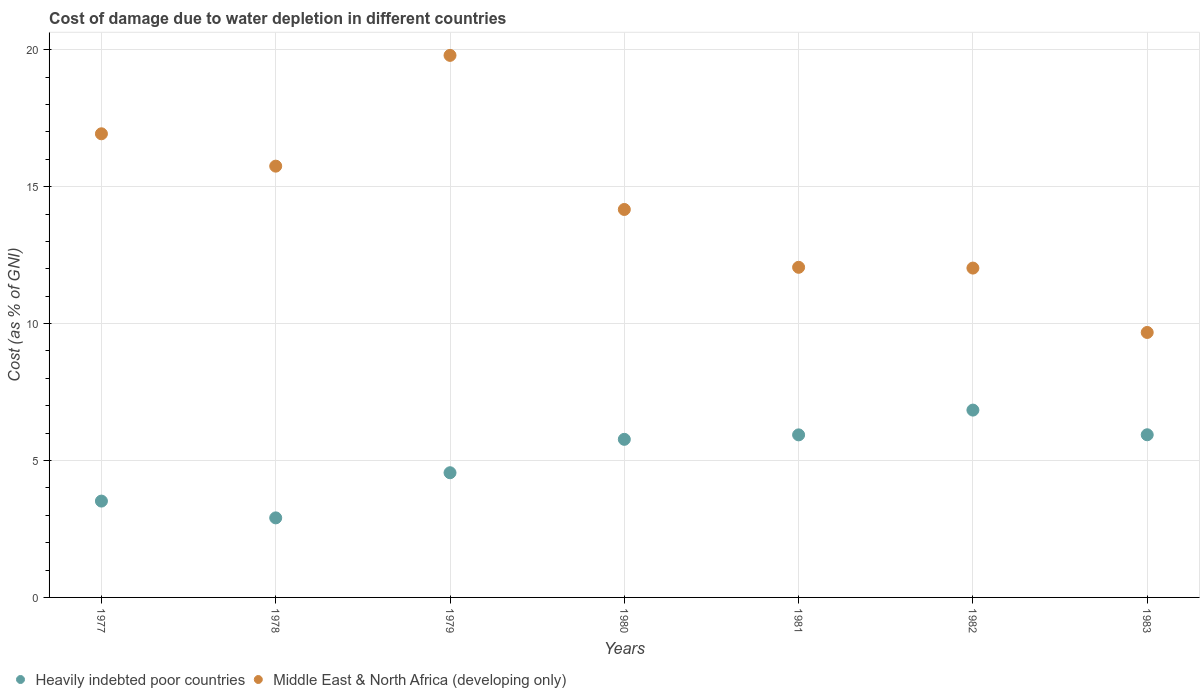How many different coloured dotlines are there?
Your answer should be very brief. 2. What is the cost of damage caused due to water depletion in Middle East & North Africa (developing only) in 1983?
Offer a very short reply. 9.68. Across all years, what is the maximum cost of damage caused due to water depletion in Heavily indebted poor countries?
Your answer should be very brief. 6.84. Across all years, what is the minimum cost of damage caused due to water depletion in Heavily indebted poor countries?
Provide a short and direct response. 2.9. In which year was the cost of damage caused due to water depletion in Heavily indebted poor countries maximum?
Provide a short and direct response. 1982. In which year was the cost of damage caused due to water depletion in Middle East & North Africa (developing only) minimum?
Provide a short and direct response. 1983. What is the total cost of damage caused due to water depletion in Middle East & North Africa (developing only) in the graph?
Provide a short and direct response. 100.4. What is the difference between the cost of damage caused due to water depletion in Middle East & North Africa (developing only) in 1979 and that in 1983?
Your response must be concise. 10.12. What is the difference between the cost of damage caused due to water depletion in Middle East & North Africa (developing only) in 1981 and the cost of damage caused due to water depletion in Heavily indebted poor countries in 1980?
Provide a short and direct response. 6.28. What is the average cost of damage caused due to water depletion in Heavily indebted poor countries per year?
Your answer should be very brief. 5.07. In the year 1981, what is the difference between the cost of damage caused due to water depletion in Middle East & North Africa (developing only) and cost of damage caused due to water depletion in Heavily indebted poor countries?
Make the answer very short. 6.12. In how many years, is the cost of damage caused due to water depletion in Heavily indebted poor countries greater than 3 %?
Offer a very short reply. 6. What is the ratio of the cost of damage caused due to water depletion in Heavily indebted poor countries in 1979 to that in 1980?
Ensure brevity in your answer.  0.79. Is the cost of damage caused due to water depletion in Heavily indebted poor countries in 1978 less than that in 1981?
Provide a succinct answer. Yes. Is the difference between the cost of damage caused due to water depletion in Middle East & North Africa (developing only) in 1979 and 1981 greater than the difference between the cost of damage caused due to water depletion in Heavily indebted poor countries in 1979 and 1981?
Give a very brief answer. Yes. What is the difference between the highest and the second highest cost of damage caused due to water depletion in Middle East & North Africa (developing only)?
Make the answer very short. 2.86. What is the difference between the highest and the lowest cost of damage caused due to water depletion in Heavily indebted poor countries?
Provide a short and direct response. 3.94. Is the sum of the cost of damage caused due to water depletion in Heavily indebted poor countries in 1981 and 1982 greater than the maximum cost of damage caused due to water depletion in Middle East & North Africa (developing only) across all years?
Offer a very short reply. No. Is the cost of damage caused due to water depletion in Heavily indebted poor countries strictly greater than the cost of damage caused due to water depletion in Middle East & North Africa (developing only) over the years?
Make the answer very short. No. Does the graph contain any zero values?
Ensure brevity in your answer.  No. How many legend labels are there?
Provide a short and direct response. 2. How are the legend labels stacked?
Provide a short and direct response. Horizontal. What is the title of the graph?
Make the answer very short. Cost of damage due to water depletion in different countries. What is the label or title of the X-axis?
Offer a terse response. Years. What is the label or title of the Y-axis?
Make the answer very short. Cost (as % of GNI). What is the Cost (as % of GNI) of Heavily indebted poor countries in 1977?
Your answer should be very brief. 3.52. What is the Cost (as % of GNI) in Middle East & North Africa (developing only) in 1977?
Ensure brevity in your answer.  16.93. What is the Cost (as % of GNI) in Heavily indebted poor countries in 1978?
Give a very brief answer. 2.9. What is the Cost (as % of GNI) of Middle East & North Africa (developing only) in 1978?
Your response must be concise. 15.75. What is the Cost (as % of GNI) of Heavily indebted poor countries in 1979?
Provide a short and direct response. 4.55. What is the Cost (as % of GNI) in Middle East & North Africa (developing only) in 1979?
Your answer should be compact. 19.79. What is the Cost (as % of GNI) in Heavily indebted poor countries in 1980?
Provide a succinct answer. 5.77. What is the Cost (as % of GNI) in Middle East & North Africa (developing only) in 1980?
Offer a very short reply. 14.17. What is the Cost (as % of GNI) of Heavily indebted poor countries in 1981?
Provide a succinct answer. 5.94. What is the Cost (as % of GNI) in Middle East & North Africa (developing only) in 1981?
Your response must be concise. 12.05. What is the Cost (as % of GNI) of Heavily indebted poor countries in 1982?
Ensure brevity in your answer.  6.84. What is the Cost (as % of GNI) of Middle East & North Africa (developing only) in 1982?
Offer a terse response. 12.03. What is the Cost (as % of GNI) of Heavily indebted poor countries in 1983?
Make the answer very short. 5.94. What is the Cost (as % of GNI) in Middle East & North Africa (developing only) in 1983?
Provide a succinct answer. 9.68. Across all years, what is the maximum Cost (as % of GNI) of Heavily indebted poor countries?
Provide a succinct answer. 6.84. Across all years, what is the maximum Cost (as % of GNI) in Middle East & North Africa (developing only)?
Your response must be concise. 19.79. Across all years, what is the minimum Cost (as % of GNI) of Heavily indebted poor countries?
Your response must be concise. 2.9. Across all years, what is the minimum Cost (as % of GNI) in Middle East & North Africa (developing only)?
Provide a short and direct response. 9.68. What is the total Cost (as % of GNI) of Heavily indebted poor countries in the graph?
Offer a terse response. 35.47. What is the total Cost (as % of GNI) in Middle East & North Africa (developing only) in the graph?
Your answer should be compact. 100.4. What is the difference between the Cost (as % of GNI) of Heavily indebted poor countries in 1977 and that in 1978?
Keep it short and to the point. 0.61. What is the difference between the Cost (as % of GNI) in Middle East & North Africa (developing only) in 1977 and that in 1978?
Provide a succinct answer. 1.18. What is the difference between the Cost (as % of GNI) in Heavily indebted poor countries in 1977 and that in 1979?
Provide a succinct answer. -1.04. What is the difference between the Cost (as % of GNI) of Middle East & North Africa (developing only) in 1977 and that in 1979?
Your response must be concise. -2.86. What is the difference between the Cost (as % of GNI) of Heavily indebted poor countries in 1977 and that in 1980?
Keep it short and to the point. -2.26. What is the difference between the Cost (as % of GNI) in Middle East & North Africa (developing only) in 1977 and that in 1980?
Your answer should be compact. 2.76. What is the difference between the Cost (as % of GNI) of Heavily indebted poor countries in 1977 and that in 1981?
Provide a short and direct response. -2.42. What is the difference between the Cost (as % of GNI) of Middle East & North Africa (developing only) in 1977 and that in 1981?
Provide a short and direct response. 4.88. What is the difference between the Cost (as % of GNI) in Heavily indebted poor countries in 1977 and that in 1982?
Your response must be concise. -3.32. What is the difference between the Cost (as % of GNI) of Middle East & North Africa (developing only) in 1977 and that in 1982?
Keep it short and to the point. 4.9. What is the difference between the Cost (as % of GNI) in Heavily indebted poor countries in 1977 and that in 1983?
Ensure brevity in your answer.  -2.42. What is the difference between the Cost (as % of GNI) of Middle East & North Africa (developing only) in 1977 and that in 1983?
Provide a succinct answer. 7.25. What is the difference between the Cost (as % of GNI) of Heavily indebted poor countries in 1978 and that in 1979?
Ensure brevity in your answer.  -1.65. What is the difference between the Cost (as % of GNI) in Middle East & North Africa (developing only) in 1978 and that in 1979?
Provide a succinct answer. -4.04. What is the difference between the Cost (as % of GNI) in Heavily indebted poor countries in 1978 and that in 1980?
Your response must be concise. -2.87. What is the difference between the Cost (as % of GNI) in Middle East & North Africa (developing only) in 1978 and that in 1980?
Your answer should be very brief. 1.58. What is the difference between the Cost (as % of GNI) of Heavily indebted poor countries in 1978 and that in 1981?
Your response must be concise. -3.03. What is the difference between the Cost (as % of GNI) of Middle East & North Africa (developing only) in 1978 and that in 1981?
Your response must be concise. 3.69. What is the difference between the Cost (as % of GNI) in Heavily indebted poor countries in 1978 and that in 1982?
Offer a terse response. -3.94. What is the difference between the Cost (as % of GNI) in Middle East & North Africa (developing only) in 1978 and that in 1982?
Your response must be concise. 3.72. What is the difference between the Cost (as % of GNI) of Heavily indebted poor countries in 1978 and that in 1983?
Provide a succinct answer. -3.03. What is the difference between the Cost (as % of GNI) of Middle East & North Africa (developing only) in 1978 and that in 1983?
Keep it short and to the point. 6.07. What is the difference between the Cost (as % of GNI) in Heavily indebted poor countries in 1979 and that in 1980?
Provide a succinct answer. -1.22. What is the difference between the Cost (as % of GNI) in Middle East & North Africa (developing only) in 1979 and that in 1980?
Keep it short and to the point. 5.63. What is the difference between the Cost (as % of GNI) of Heavily indebted poor countries in 1979 and that in 1981?
Provide a short and direct response. -1.38. What is the difference between the Cost (as % of GNI) of Middle East & North Africa (developing only) in 1979 and that in 1981?
Provide a short and direct response. 7.74. What is the difference between the Cost (as % of GNI) in Heavily indebted poor countries in 1979 and that in 1982?
Your response must be concise. -2.29. What is the difference between the Cost (as % of GNI) of Middle East & North Africa (developing only) in 1979 and that in 1982?
Keep it short and to the point. 7.77. What is the difference between the Cost (as % of GNI) of Heavily indebted poor countries in 1979 and that in 1983?
Provide a succinct answer. -1.39. What is the difference between the Cost (as % of GNI) in Middle East & North Africa (developing only) in 1979 and that in 1983?
Your answer should be very brief. 10.12. What is the difference between the Cost (as % of GNI) in Heavily indebted poor countries in 1980 and that in 1981?
Offer a very short reply. -0.16. What is the difference between the Cost (as % of GNI) of Middle East & North Africa (developing only) in 1980 and that in 1981?
Offer a very short reply. 2.11. What is the difference between the Cost (as % of GNI) in Heavily indebted poor countries in 1980 and that in 1982?
Provide a short and direct response. -1.07. What is the difference between the Cost (as % of GNI) of Middle East & North Africa (developing only) in 1980 and that in 1982?
Provide a succinct answer. 2.14. What is the difference between the Cost (as % of GNI) of Heavily indebted poor countries in 1980 and that in 1983?
Ensure brevity in your answer.  -0.17. What is the difference between the Cost (as % of GNI) of Middle East & North Africa (developing only) in 1980 and that in 1983?
Your answer should be very brief. 4.49. What is the difference between the Cost (as % of GNI) in Heavily indebted poor countries in 1981 and that in 1982?
Make the answer very short. -0.9. What is the difference between the Cost (as % of GNI) in Middle East & North Africa (developing only) in 1981 and that in 1982?
Ensure brevity in your answer.  0.03. What is the difference between the Cost (as % of GNI) in Heavily indebted poor countries in 1981 and that in 1983?
Make the answer very short. -0. What is the difference between the Cost (as % of GNI) of Middle East & North Africa (developing only) in 1981 and that in 1983?
Make the answer very short. 2.38. What is the difference between the Cost (as % of GNI) in Heavily indebted poor countries in 1982 and that in 1983?
Keep it short and to the point. 0.9. What is the difference between the Cost (as % of GNI) in Middle East & North Africa (developing only) in 1982 and that in 1983?
Offer a terse response. 2.35. What is the difference between the Cost (as % of GNI) in Heavily indebted poor countries in 1977 and the Cost (as % of GNI) in Middle East & North Africa (developing only) in 1978?
Your answer should be compact. -12.23. What is the difference between the Cost (as % of GNI) in Heavily indebted poor countries in 1977 and the Cost (as % of GNI) in Middle East & North Africa (developing only) in 1979?
Offer a terse response. -16.28. What is the difference between the Cost (as % of GNI) in Heavily indebted poor countries in 1977 and the Cost (as % of GNI) in Middle East & North Africa (developing only) in 1980?
Your answer should be compact. -10.65. What is the difference between the Cost (as % of GNI) in Heavily indebted poor countries in 1977 and the Cost (as % of GNI) in Middle East & North Africa (developing only) in 1981?
Make the answer very short. -8.54. What is the difference between the Cost (as % of GNI) of Heavily indebted poor countries in 1977 and the Cost (as % of GNI) of Middle East & North Africa (developing only) in 1982?
Offer a terse response. -8.51. What is the difference between the Cost (as % of GNI) in Heavily indebted poor countries in 1977 and the Cost (as % of GNI) in Middle East & North Africa (developing only) in 1983?
Give a very brief answer. -6.16. What is the difference between the Cost (as % of GNI) in Heavily indebted poor countries in 1978 and the Cost (as % of GNI) in Middle East & North Africa (developing only) in 1979?
Give a very brief answer. -16.89. What is the difference between the Cost (as % of GNI) in Heavily indebted poor countries in 1978 and the Cost (as % of GNI) in Middle East & North Africa (developing only) in 1980?
Ensure brevity in your answer.  -11.26. What is the difference between the Cost (as % of GNI) in Heavily indebted poor countries in 1978 and the Cost (as % of GNI) in Middle East & North Africa (developing only) in 1981?
Ensure brevity in your answer.  -9.15. What is the difference between the Cost (as % of GNI) of Heavily indebted poor countries in 1978 and the Cost (as % of GNI) of Middle East & North Africa (developing only) in 1982?
Your answer should be compact. -9.12. What is the difference between the Cost (as % of GNI) in Heavily indebted poor countries in 1978 and the Cost (as % of GNI) in Middle East & North Africa (developing only) in 1983?
Your response must be concise. -6.77. What is the difference between the Cost (as % of GNI) of Heavily indebted poor countries in 1979 and the Cost (as % of GNI) of Middle East & North Africa (developing only) in 1980?
Your answer should be compact. -9.61. What is the difference between the Cost (as % of GNI) of Heavily indebted poor countries in 1979 and the Cost (as % of GNI) of Middle East & North Africa (developing only) in 1981?
Your answer should be very brief. -7.5. What is the difference between the Cost (as % of GNI) of Heavily indebted poor countries in 1979 and the Cost (as % of GNI) of Middle East & North Africa (developing only) in 1982?
Make the answer very short. -7.47. What is the difference between the Cost (as % of GNI) in Heavily indebted poor countries in 1979 and the Cost (as % of GNI) in Middle East & North Africa (developing only) in 1983?
Provide a short and direct response. -5.12. What is the difference between the Cost (as % of GNI) in Heavily indebted poor countries in 1980 and the Cost (as % of GNI) in Middle East & North Africa (developing only) in 1981?
Provide a succinct answer. -6.28. What is the difference between the Cost (as % of GNI) of Heavily indebted poor countries in 1980 and the Cost (as % of GNI) of Middle East & North Africa (developing only) in 1982?
Your response must be concise. -6.25. What is the difference between the Cost (as % of GNI) of Heavily indebted poor countries in 1980 and the Cost (as % of GNI) of Middle East & North Africa (developing only) in 1983?
Your answer should be very brief. -3.9. What is the difference between the Cost (as % of GNI) in Heavily indebted poor countries in 1981 and the Cost (as % of GNI) in Middle East & North Africa (developing only) in 1982?
Your answer should be very brief. -6.09. What is the difference between the Cost (as % of GNI) of Heavily indebted poor countries in 1981 and the Cost (as % of GNI) of Middle East & North Africa (developing only) in 1983?
Keep it short and to the point. -3.74. What is the difference between the Cost (as % of GNI) in Heavily indebted poor countries in 1982 and the Cost (as % of GNI) in Middle East & North Africa (developing only) in 1983?
Provide a short and direct response. -2.83. What is the average Cost (as % of GNI) in Heavily indebted poor countries per year?
Provide a short and direct response. 5.07. What is the average Cost (as % of GNI) in Middle East & North Africa (developing only) per year?
Your answer should be compact. 14.34. In the year 1977, what is the difference between the Cost (as % of GNI) of Heavily indebted poor countries and Cost (as % of GNI) of Middle East & North Africa (developing only)?
Ensure brevity in your answer.  -13.41. In the year 1978, what is the difference between the Cost (as % of GNI) in Heavily indebted poor countries and Cost (as % of GNI) in Middle East & North Africa (developing only)?
Your response must be concise. -12.84. In the year 1979, what is the difference between the Cost (as % of GNI) in Heavily indebted poor countries and Cost (as % of GNI) in Middle East & North Africa (developing only)?
Provide a succinct answer. -15.24. In the year 1980, what is the difference between the Cost (as % of GNI) of Heavily indebted poor countries and Cost (as % of GNI) of Middle East & North Africa (developing only)?
Your answer should be very brief. -8.39. In the year 1981, what is the difference between the Cost (as % of GNI) of Heavily indebted poor countries and Cost (as % of GNI) of Middle East & North Africa (developing only)?
Provide a succinct answer. -6.12. In the year 1982, what is the difference between the Cost (as % of GNI) in Heavily indebted poor countries and Cost (as % of GNI) in Middle East & North Africa (developing only)?
Your answer should be compact. -5.19. In the year 1983, what is the difference between the Cost (as % of GNI) in Heavily indebted poor countries and Cost (as % of GNI) in Middle East & North Africa (developing only)?
Provide a succinct answer. -3.74. What is the ratio of the Cost (as % of GNI) in Heavily indebted poor countries in 1977 to that in 1978?
Provide a short and direct response. 1.21. What is the ratio of the Cost (as % of GNI) in Middle East & North Africa (developing only) in 1977 to that in 1978?
Your answer should be very brief. 1.07. What is the ratio of the Cost (as % of GNI) in Heavily indebted poor countries in 1977 to that in 1979?
Ensure brevity in your answer.  0.77. What is the ratio of the Cost (as % of GNI) of Middle East & North Africa (developing only) in 1977 to that in 1979?
Provide a succinct answer. 0.86. What is the ratio of the Cost (as % of GNI) in Heavily indebted poor countries in 1977 to that in 1980?
Provide a succinct answer. 0.61. What is the ratio of the Cost (as % of GNI) of Middle East & North Africa (developing only) in 1977 to that in 1980?
Your answer should be very brief. 1.2. What is the ratio of the Cost (as % of GNI) in Heavily indebted poor countries in 1977 to that in 1981?
Offer a very short reply. 0.59. What is the ratio of the Cost (as % of GNI) in Middle East & North Africa (developing only) in 1977 to that in 1981?
Provide a succinct answer. 1.4. What is the ratio of the Cost (as % of GNI) of Heavily indebted poor countries in 1977 to that in 1982?
Provide a succinct answer. 0.51. What is the ratio of the Cost (as % of GNI) in Middle East & North Africa (developing only) in 1977 to that in 1982?
Offer a very short reply. 1.41. What is the ratio of the Cost (as % of GNI) of Heavily indebted poor countries in 1977 to that in 1983?
Provide a succinct answer. 0.59. What is the ratio of the Cost (as % of GNI) in Middle East & North Africa (developing only) in 1977 to that in 1983?
Your response must be concise. 1.75. What is the ratio of the Cost (as % of GNI) in Heavily indebted poor countries in 1978 to that in 1979?
Give a very brief answer. 0.64. What is the ratio of the Cost (as % of GNI) in Middle East & North Africa (developing only) in 1978 to that in 1979?
Provide a short and direct response. 0.8. What is the ratio of the Cost (as % of GNI) of Heavily indebted poor countries in 1978 to that in 1980?
Offer a terse response. 0.5. What is the ratio of the Cost (as % of GNI) of Middle East & North Africa (developing only) in 1978 to that in 1980?
Keep it short and to the point. 1.11. What is the ratio of the Cost (as % of GNI) of Heavily indebted poor countries in 1978 to that in 1981?
Give a very brief answer. 0.49. What is the ratio of the Cost (as % of GNI) in Middle East & North Africa (developing only) in 1978 to that in 1981?
Your answer should be very brief. 1.31. What is the ratio of the Cost (as % of GNI) of Heavily indebted poor countries in 1978 to that in 1982?
Provide a short and direct response. 0.42. What is the ratio of the Cost (as % of GNI) of Middle East & North Africa (developing only) in 1978 to that in 1982?
Offer a very short reply. 1.31. What is the ratio of the Cost (as % of GNI) of Heavily indebted poor countries in 1978 to that in 1983?
Your answer should be compact. 0.49. What is the ratio of the Cost (as % of GNI) in Middle East & North Africa (developing only) in 1978 to that in 1983?
Your answer should be compact. 1.63. What is the ratio of the Cost (as % of GNI) of Heavily indebted poor countries in 1979 to that in 1980?
Offer a very short reply. 0.79. What is the ratio of the Cost (as % of GNI) in Middle East & North Africa (developing only) in 1979 to that in 1980?
Make the answer very short. 1.4. What is the ratio of the Cost (as % of GNI) of Heavily indebted poor countries in 1979 to that in 1981?
Offer a terse response. 0.77. What is the ratio of the Cost (as % of GNI) of Middle East & North Africa (developing only) in 1979 to that in 1981?
Offer a very short reply. 1.64. What is the ratio of the Cost (as % of GNI) in Heavily indebted poor countries in 1979 to that in 1982?
Keep it short and to the point. 0.67. What is the ratio of the Cost (as % of GNI) of Middle East & North Africa (developing only) in 1979 to that in 1982?
Make the answer very short. 1.65. What is the ratio of the Cost (as % of GNI) in Heavily indebted poor countries in 1979 to that in 1983?
Keep it short and to the point. 0.77. What is the ratio of the Cost (as % of GNI) of Middle East & North Africa (developing only) in 1979 to that in 1983?
Keep it short and to the point. 2.05. What is the ratio of the Cost (as % of GNI) of Heavily indebted poor countries in 1980 to that in 1981?
Your answer should be compact. 0.97. What is the ratio of the Cost (as % of GNI) in Middle East & North Africa (developing only) in 1980 to that in 1981?
Make the answer very short. 1.18. What is the ratio of the Cost (as % of GNI) in Heavily indebted poor countries in 1980 to that in 1982?
Offer a terse response. 0.84. What is the ratio of the Cost (as % of GNI) of Middle East & North Africa (developing only) in 1980 to that in 1982?
Your answer should be very brief. 1.18. What is the ratio of the Cost (as % of GNI) in Heavily indebted poor countries in 1980 to that in 1983?
Provide a short and direct response. 0.97. What is the ratio of the Cost (as % of GNI) in Middle East & North Africa (developing only) in 1980 to that in 1983?
Give a very brief answer. 1.46. What is the ratio of the Cost (as % of GNI) of Heavily indebted poor countries in 1981 to that in 1982?
Provide a succinct answer. 0.87. What is the ratio of the Cost (as % of GNI) of Middle East & North Africa (developing only) in 1981 to that in 1982?
Provide a succinct answer. 1. What is the ratio of the Cost (as % of GNI) in Middle East & North Africa (developing only) in 1981 to that in 1983?
Make the answer very short. 1.25. What is the ratio of the Cost (as % of GNI) in Heavily indebted poor countries in 1982 to that in 1983?
Offer a terse response. 1.15. What is the ratio of the Cost (as % of GNI) in Middle East & North Africa (developing only) in 1982 to that in 1983?
Keep it short and to the point. 1.24. What is the difference between the highest and the second highest Cost (as % of GNI) of Heavily indebted poor countries?
Make the answer very short. 0.9. What is the difference between the highest and the second highest Cost (as % of GNI) in Middle East & North Africa (developing only)?
Your answer should be very brief. 2.86. What is the difference between the highest and the lowest Cost (as % of GNI) of Heavily indebted poor countries?
Make the answer very short. 3.94. What is the difference between the highest and the lowest Cost (as % of GNI) in Middle East & North Africa (developing only)?
Offer a very short reply. 10.12. 